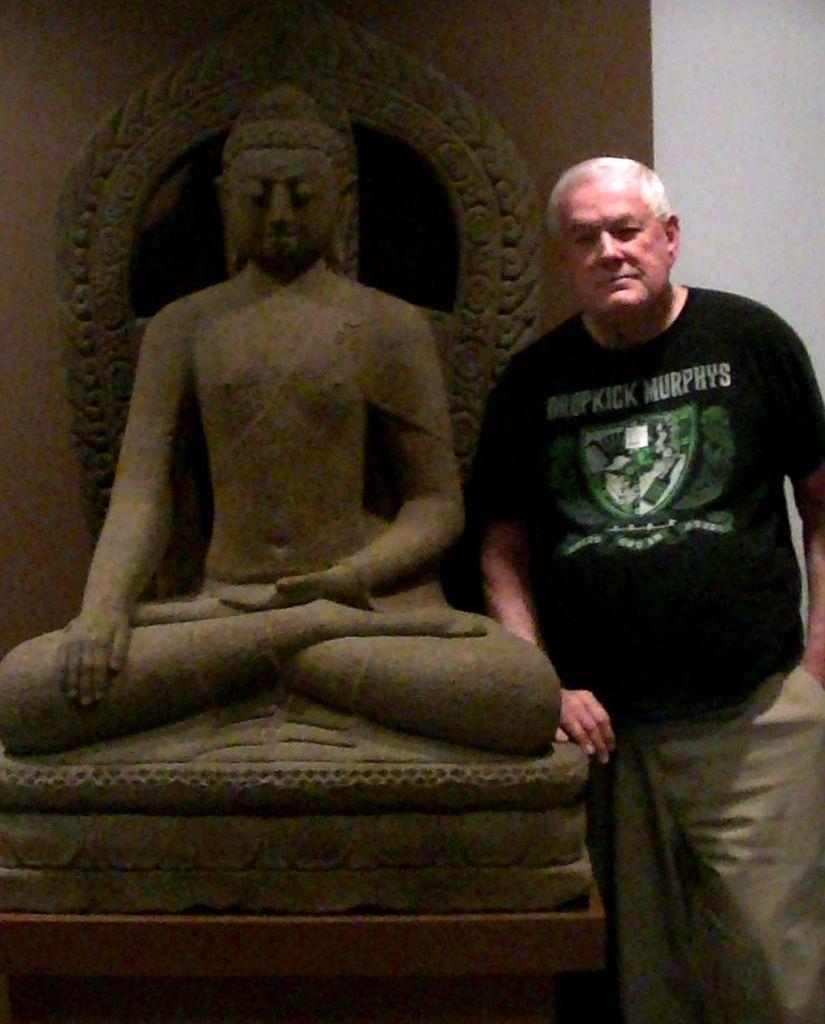In one or two sentences, can you explain what this image depicts? In this picture we can see a man, he is standing near to the statue, and he wore a black color T-shirt. 